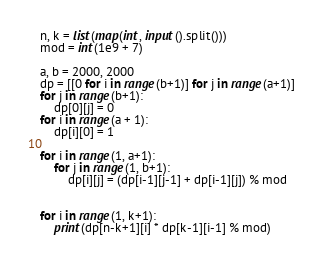Convert code to text. <code><loc_0><loc_0><loc_500><loc_500><_Python_>n, k = list(map(int, input().split()))
mod = int(1e9 + 7)

a, b = 2000, 2000
dp = [[0 for i in range(b+1)] for j in range(a+1)]
for j in range(b+1):
    dp[0][j] = 0
for i in range(a + 1):
    dp[i][0] = 1

for i in range(1, a+1):
    for j in range(1, b+1):
        dp[i][j] = (dp[i-1][j-1] + dp[i-1][j]) % mod


for i in range(1, k+1):
    print(dp[n-k+1][i] * dp[k-1][i-1] % mod)
</code> 